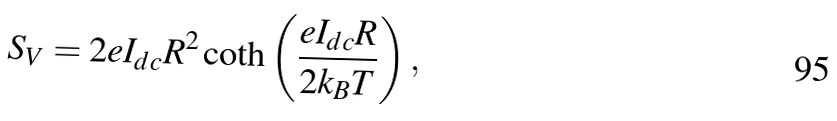Convert formula to latex. <formula><loc_0><loc_0><loc_500><loc_500>S _ { V } = 2 e I _ { d c } R ^ { 2 } \coth \left ( \frac { e I _ { d c } R } { 2 k _ { B } T } \right ) ,</formula> 